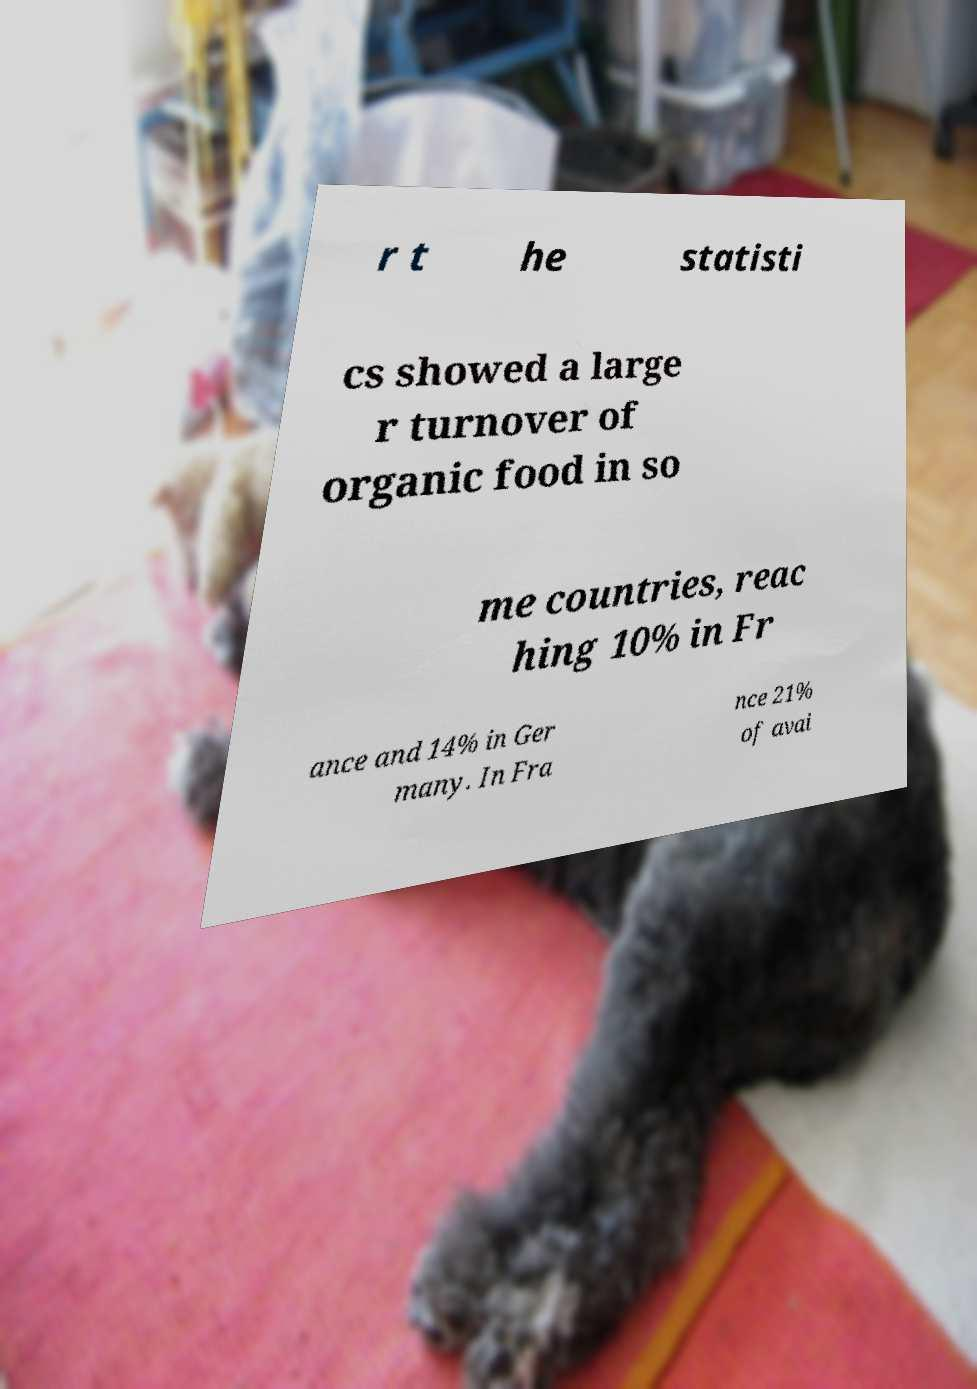Can you accurately transcribe the text from the provided image for me? r t he statisti cs showed a large r turnover of organic food in so me countries, reac hing 10% in Fr ance and 14% in Ger many. In Fra nce 21% of avai 